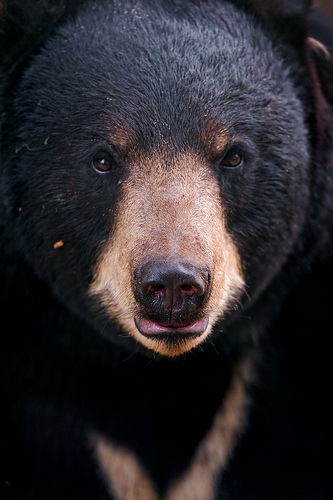Please provide the bounding box coordinate of the region this sentence describes: Tan fur on a bear's nose. The bounding box coordinates for the tan fur on the bear's nose are [0.4, 0.27, 0.61, 0.52]. This region includes the tan fur that is prominently visible on the bear's nose area. 